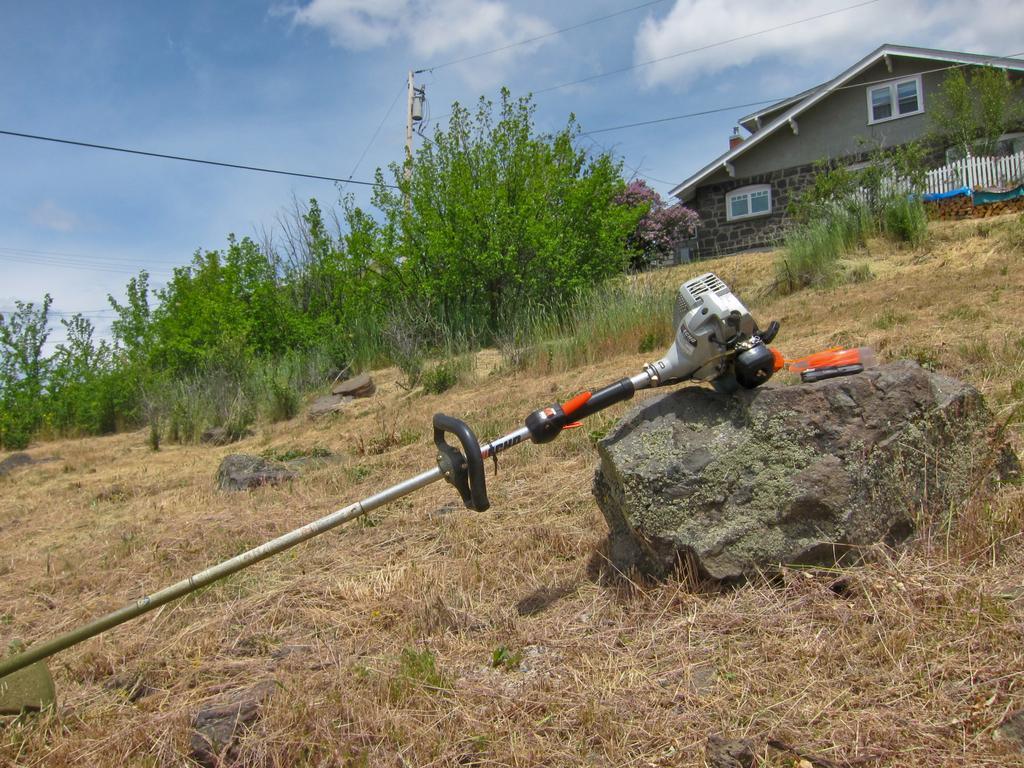Please provide a concise description of this image. In this image, we can see a rod with device on the stone. Here we can see stones, grass and plants. Background we can see house, wall, windows, pole, fence, wires and sky. 